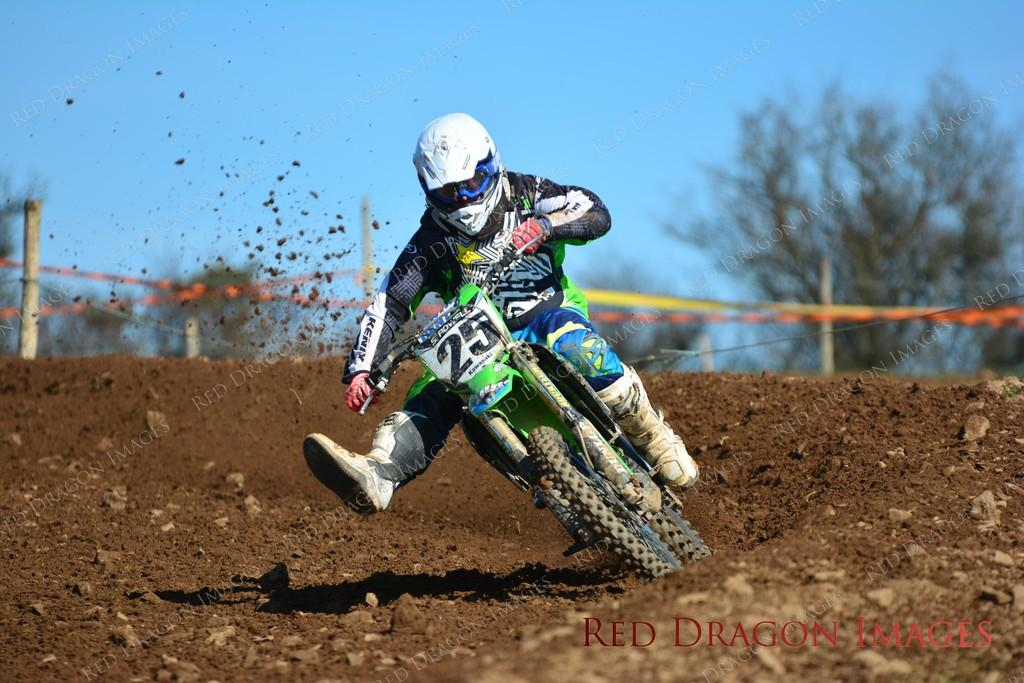Provide a one-sentence caption for the provided image. A dirt bike rider wearing the number 25 races around the corner. 